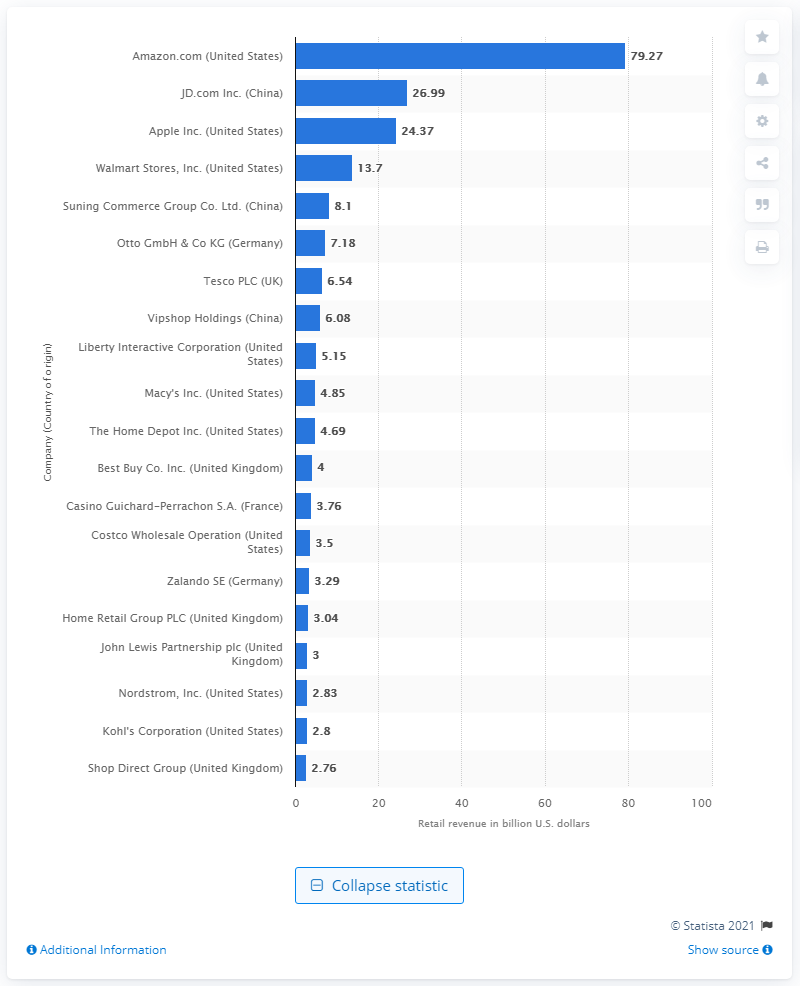Highlight a few significant elements in this photo. In 2015, Amazon generated approximately 79.27 billion dollars in revenue in the United States. 